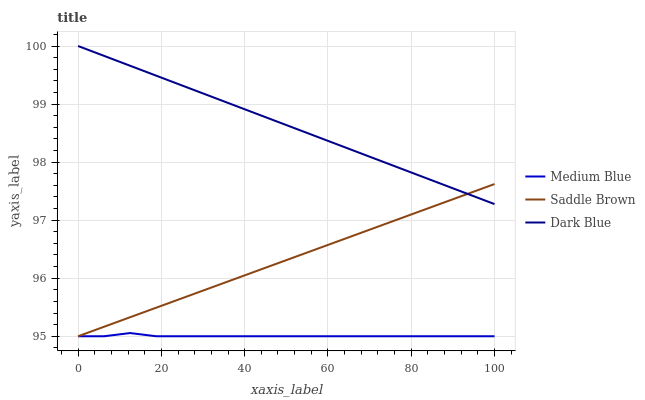Does Medium Blue have the minimum area under the curve?
Answer yes or no. Yes. Does Dark Blue have the maximum area under the curve?
Answer yes or no. Yes. Does Saddle Brown have the minimum area under the curve?
Answer yes or no. No. Does Saddle Brown have the maximum area under the curve?
Answer yes or no. No. Is Dark Blue the smoothest?
Answer yes or no. Yes. Is Medium Blue the roughest?
Answer yes or no. Yes. Is Saddle Brown the smoothest?
Answer yes or no. No. Is Saddle Brown the roughest?
Answer yes or no. No. Does Medium Blue have the lowest value?
Answer yes or no. Yes. Does Dark Blue have the highest value?
Answer yes or no. Yes. Does Saddle Brown have the highest value?
Answer yes or no. No. Is Medium Blue less than Dark Blue?
Answer yes or no. Yes. Is Dark Blue greater than Medium Blue?
Answer yes or no. Yes. Does Medium Blue intersect Saddle Brown?
Answer yes or no. Yes. Is Medium Blue less than Saddle Brown?
Answer yes or no. No. Is Medium Blue greater than Saddle Brown?
Answer yes or no. No. Does Medium Blue intersect Dark Blue?
Answer yes or no. No. 